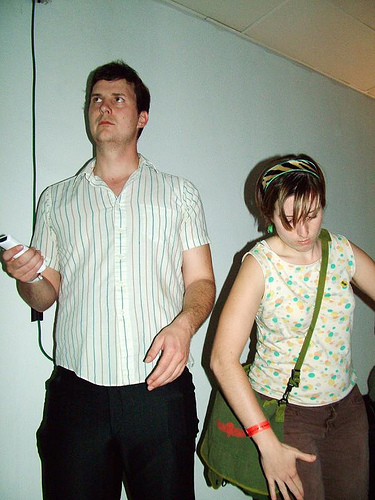<image>How many babies are in the house? It is unknown how many babies are in the house. How many babies are in the house? There are no babies in the house. 